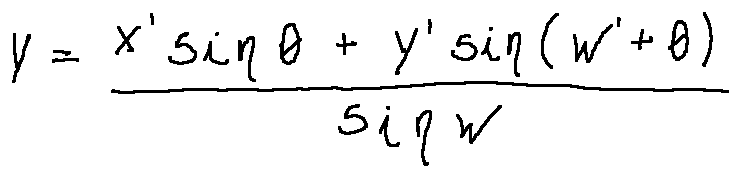Convert formula to latex. <formula><loc_0><loc_0><loc_500><loc_500>y = \frac { x \prime \sin \theta + y \prime \sin ( w \prime + \theta ) } { \sin w }</formula> 